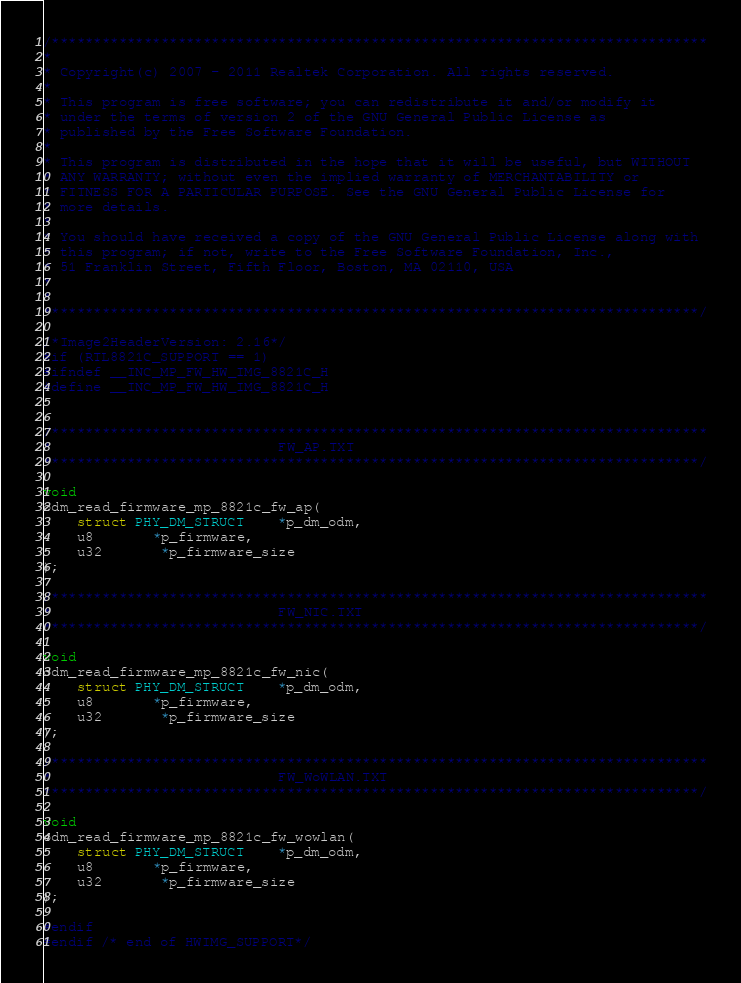<code> <loc_0><loc_0><loc_500><loc_500><_C_>/******************************************************************************
*
* Copyright(c) 2007 - 2011 Realtek Corporation. All rights reserved.
*
* This program is free software; you can redistribute it and/or modify it
* under the terms of version 2 of the GNU General Public License as
* published by the Free Software Foundation.
*
* This program is distributed in the hope that it will be useful, but WITHOUT
* ANY WARRANTY; without even the implied warranty of MERCHANTABILITY or
* FITNESS FOR A PARTICULAR PURPOSE. See the GNU General Public License for
* more details.
*
* You should have received a copy of the GNU General Public License along with
* this program; if not, write to the Free Software Foundation, Inc.,
* 51 Franklin Street, Fifth Floor, Boston, MA 02110, USA
*
*
******************************************************************************/

/*Image2HeaderVersion: 2.16*/
#if (RTL8821C_SUPPORT == 1)
#ifndef __INC_MP_FW_HW_IMG_8821C_H
#define __INC_MP_FW_HW_IMG_8821C_H


/******************************************************************************
*                           FW_AP.TXT
******************************************************************************/

void
odm_read_firmware_mp_8821c_fw_ap(
	struct PHY_DM_STRUCT    *p_dm_odm,
	u8       *p_firmware,
	u32       *p_firmware_size
);

/******************************************************************************
*                           FW_NIC.TXT
******************************************************************************/

void
odm_read_firmware_mp_8821c_fw_nic(
	struct PHY_DM_STRUCT    *p_dm_odm,
	u8       *p_firmware,
	u32       *p_firmware_size
);

/******************************************************************************
*                           FW_WoWLAN.TXT
******************************************************************************/

void
odm_read_firmware_mp_8821c_fw_wowlan(
	struct PHY_DM_STRUCT    *p_dm_odm,
	u8       *p_firmware,
	u32       *p_firmware_size
);

#endif
#endif /* end of HWIMG_SUPPORT*/
</code> 